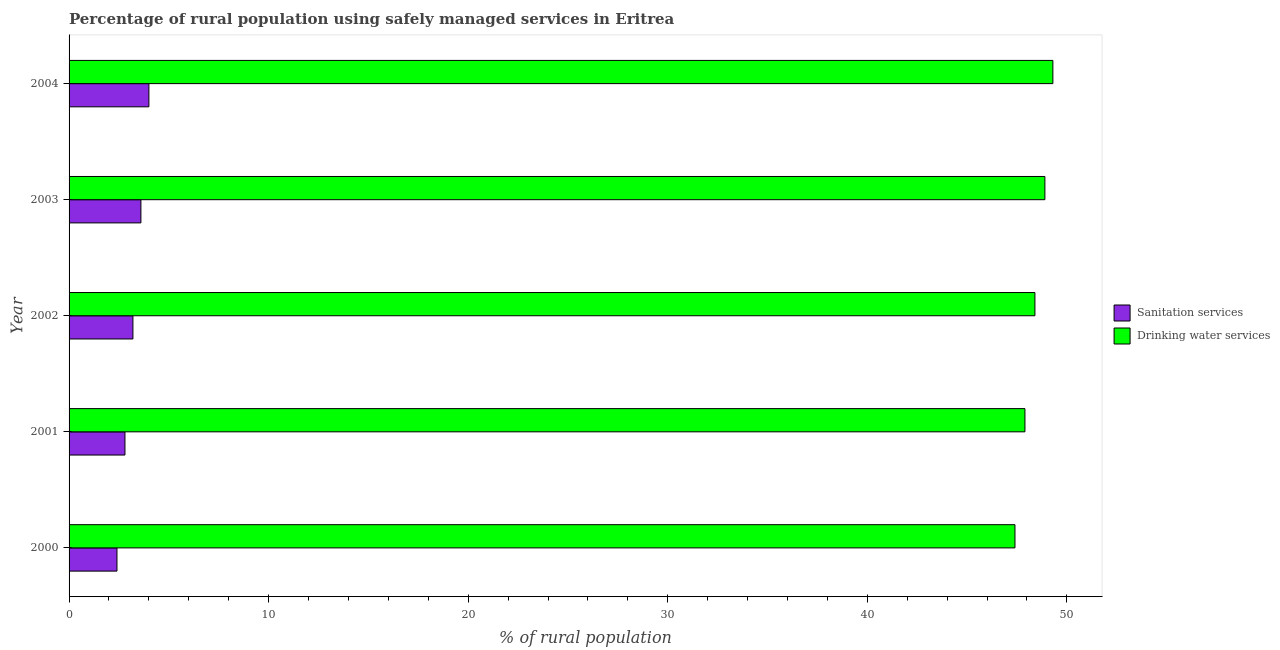Are the number of bars per tick equal to the number of legend labels?
Your response must be concise. Yes. How many bars are there on the 4th tick from the bottom?
Your response must be concise. 2. What is the percentage of rural population who used drinking water services in 2002?
Ensure brevity in your answer.  48.4. Across all years, what is the maximum percentage of rural population who used sanitation services?
Provide a short and direct response. 4. In which year was the percentage of rural population who used drinking water services minimum?
Make the answer very short. 2000. What is the total percentage of rural population who used sanitation services in the graph?
Provide a succinct answer. 16. What is the difference between the percentage of rural population who used drinking water services in 2000 and that in 2002?
Make the answer very short. -1. What is the difference between the percentage of rural population who used sanitation services in 2002 and the percentage of rural population who used drinking water services in 2003?
Keep it short and to the point. -45.7. What is the average percentage of rural population who used drinking water services per year?
Offer a very short reply. 48.38. In the year 2001, what is the difference between the percentage of rural population who used drinking water services and percentage of rural population who used sanitation services?
Your answer should be very brief. 45.1. What is the difference between the highest and the second highest percentage of rural population who used drinking water services?
Provide a succinct answer. 0.4. What is the difference between the highest and the lowest percentage of rural population who used drinking water services?
Your answer should be compact. 1.9. In how many years, is the percentage of rural population who used drinking water services greater than the average percentage of rural population who used drinking water services taken over all years?
Your response must be concise. 3. What does the 2nd bar from the top in 2000 represents?
Offer a terse response. Sanitation services. What does the 2nd bar from the bottom in 2003 represents?
Make the answer very short. Drinking water services. Are all the bars in the graph horizontal?
Make the answer very short. Yes. How many years are there in the graph?
Ensure brevity in your answer.  5. Does the graph contain any zero values?
Provide a short and direct response. No. Does the graph contain grids?
Ensure brevity in your answer.  No. What is the title of the graph?
Provide a short and direct response. Percentage of rural population using safely managed services in Eritrea. Does "IMF concessional" appear as one of the legend labels in the graph?
Offer a terse response. No. What is the label or title of the X-axis?
Provide a short and direct response. % of rural population. What is the % of rural population in Sanitation services in 2000?
Keep it short and to the point. 2.4. What is the % of rural population in Drinking water services in 2000?
Make the answer very short. 47.4. What is the % of rural population in Sanitation services in 2001?
Ensure brevity in your answer.  2.8. What is the % of rural population of Drinking water services in 2001?
Ensure brevity in your answer.  47.9. What is the % of rural population in Drinking water services in 2002?
Your answer should be compact. 48.4. What is the % of rural population of Drinking water services in 2003?
Give a very brief answer. 48.9. What is the % of rural population of Drinking water services in 2004?
Ensure brevity in your answer.  49.3. Across all years, what is the maximum % of rural population in Sanitation services?
Provide a short and direct response. 4. Across all years, what is the maximum % of rural population of Drinking water services?
Your answer should be compact. 49.3. Across all years, what is the minimum % of rural population of Drinking water services?
Your answer should be very brief. 47.4. What is the total % of rural population in Sanitation services in the graph?
Your response must be concise. 16. What is the total % of rural population in Drinking water services in the graph?
Offer a very short reply. 241.9. What is the difference between the % of rural population in Drinking water services in 2000 and that in 2001?
Your answer should be compact. -0.5. What is the difference between the % of rural population in Drinking water services in 2000 and that in 2003?
Provide a short and direct response. -1.5. What is the difference between the % of rural population in Sanitation services in 2000 and that in 2004?
Provide a succinct answer. -1.6. What is the difference between the % of rural population in Drinking water services in 2000 and that in 2004?
Keep it short and to the point. -1.9. What is the difference between the % of rural population of Drinking water services in 2001 and that in 2002?
Offer a terse response. -0.5. What is the difference between the % of rural population in Sanitation services in 2001 and that in 2003?
Your answer should be compact. -0.8. What is the difference between the % of rural population of Drinking water services in 2001 and that in 2003?
Offer a terse response. -1. What is the difference between the % of rural population in Sanitation services in 2001 and that in 2004?
Your answer should be compact. -1.2. What is the difference between the % of rural population in Drinking water services in 2001 and that in 2004?
Offer a very short reply. -1.4. What is the difference between the % of rural population in Drinking water services in 2002 and that in 2003?
Ensure brevity in your answer.  -0.5. What is the difference between the % of rural population of Sanitation services in 2002 and that in 2004?
Offer a very short reply. -0.8. What is the difference between the % of rural population in Drinking water services in 2003 and that in 2004?
Give a very brief answer. -0.4. What is the difference between the % of rural population of Sanitation services in 2000 and the % of rural population of Drinking water services in 2001?
Your answer should be compact. -45.5. What is the difference between the % of rural population of Sanitation services in 2000 and the % of rural population of Drinking water services in 2002?
Ensure brevity in your answer.  -46. What is the difference between the % of rural population in Sanitation services in 2000 and the % of rural population in Drinking water services in 2003?
Keep it short and to the point. -46.5. What is the difference between the % of rural population in Sanitation services in 2000 and the % of rural population in Drinking water services in 2004?
Ensure brevity in your answer.  -46.9. What is the difference between the % of rural population of Sanitation services in 2001 and the % of rural population of Drinking water services in 2002?
Your answer should be compact. -45.6. What is the difference between the % of rural population in Sanitation services in 2001 and the % of rural population in Drinking water services in 2003?
Give a very brief answer. -46.1. What is the difference between the % of rural population in Sanitation services in 2001 and the % of rural population in Drinking water services in 2004?
Offer a very short reply. -46.5. What is the difference between the % of rural population of Sanitation services in 2002 and the % of rural population of Drinking water services in 2003?
Provide a short and direct response. -45.7. What is the difference between the % of rural population of Sanitation services in 2002 and the % of rural population of Drinking water services in 2004?
Your answer should be very brief. -46.1. What is the difference between the % of rural population of Sanitation services in 2003 and the % of rural population of Drinking water services in 2004?
Offer a terse response. -45.7. What is the average % of rural population of Sanitation services per year?
Provide a succinct answer. 3.2. What is the average % of rural population of Drinking water services per year?
Your response must be concise. 48.38. In the year 2000, what is the difference between the % of rural population in Sanitation services and % of rural population in Drinking water services?
Ensure brevity in your answer.  -45. In the year 2001, what is the difference between the % of rural population in Sanitation services and % of rural population in Drinking water services?
Provide a succinct answer. -45.1. In the year 2002, what is the difference between the % of rural population of Sanitation services and % of rural population of Drinking water services?
Your answer should be compact. -45.2. In the year 2003, what is the difference between the % of rural population in Sanitation services and % of rural population in Drinking water services?
Your answer should be compact. -45.3. In the year 2004, what is the difference between the % of rural population in Sanitation services and % of rural population in Drinking water services?
Your answer should be compact. -45.3. What is the ratio of the % of rural population in Sanitation services in 2000 to that in 2001?
Offer a terse response. 0.86. What is the ratio of the % of rural population of Drinking water services in 2000 to that in 2002?
Offer a very short reply. 0.98. What is the ratio of the % of rural population of Drinking water services in 2000 to that in 2003?
Keep it short and to the point. 0.97. What is the ratio of the % of rural population in Drinking water services in 2000 to that in 2004?
Your response must be concise. 0.96. What is the ratio of the % of rural population of Sanitation services in 2001 to that in 2003?
Provide a succinct answer. 0.78. What is the ratio of the % of rural population of Drinking water services in 2001 to that in 2003?
Provide a succinct answer. 0.98. What is the ratio of the % of rural population in Drinking water services in 2001 to that in 2004?
Provide a short and direct response. 0.97. What is the ratio of the % of rural population in Sanitation services in 2002 to that in 2003?
Give a very brief answer. 0.89. What is the ratio of the % of rural population in Drinking water services in 2002 to that in 2004?
Ensure brevity in your answer.  0.98. What is the ratio of the % of rural population in Sanitation services in 2003 to that in 2004?
Give a very brief answer. 0.9. What is the difference between the highest and the second highest % of rural population of Drinking water services?
Your answer should be very brief. 0.4. 